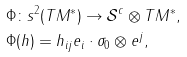<formula> <loc_0><loc_0><loc_500><loc_500>& \Phi \colon s ^ { 2 } ( T M ^ { \ast } ) \rightarrow \mathcal { S } ^ { c } \otimes T M ^ { \ast } , \\ & \Phi ( h ) = h _ { i j } e _ { i } \cdot \sigma _ { 0 } \otimes e ^ { j } ,</formula> 